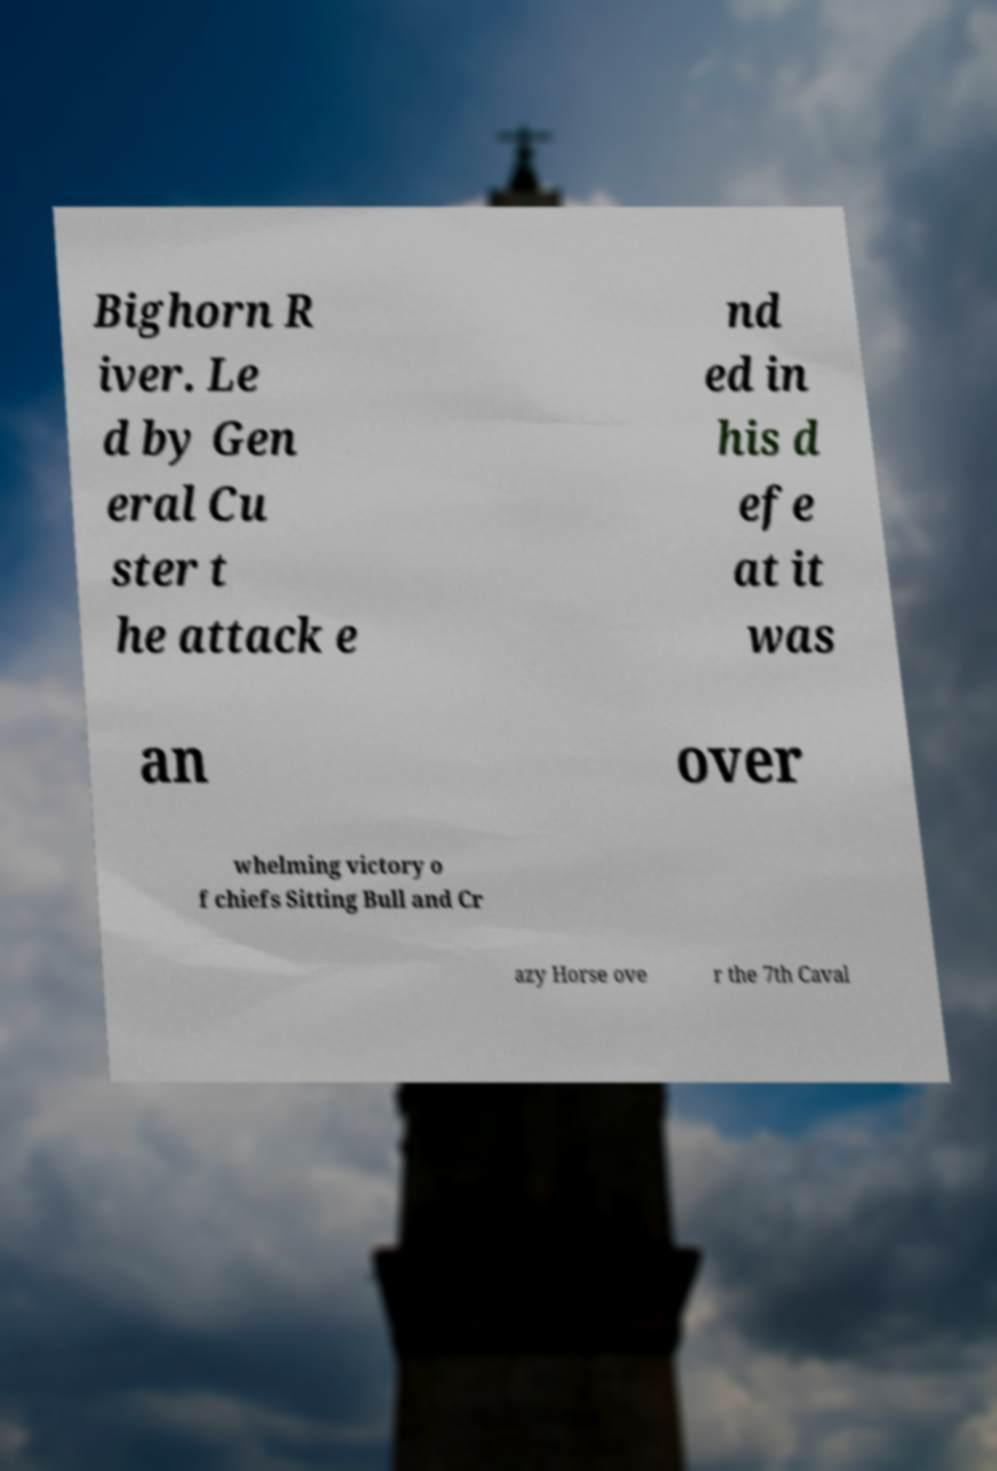Can you read and provide the text displayed in the image?This photo seems to have some interesting text. Can you extract and type it out for me? Bighorn R iver. Le d by Gen eral Cu ster t he attack e nd ed in his d efe at it was an over whelming victory o f chiefs Sitting Bull and Cr azy Horse ove r the 7th Caval 